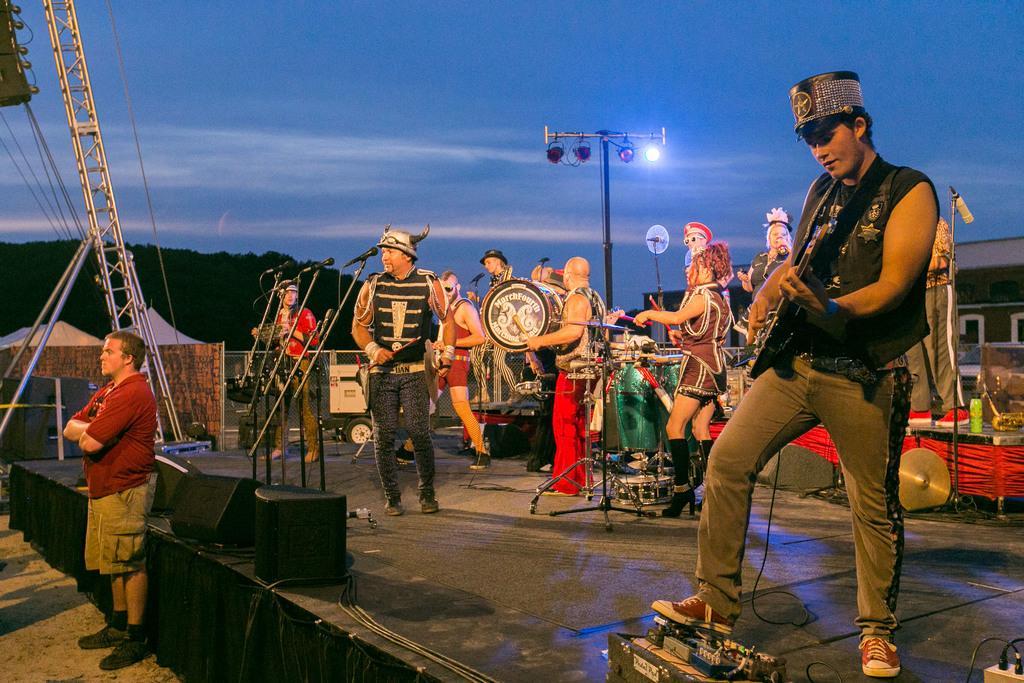How would you summarize this image in a sentence or two? In this image I can see the group of people with musical instruments. In-front of few people I can see the mics, speakers and one more person standing. In the background I can see the metal rods, poles and the house. I can also see the trees, clouds and the sky. 